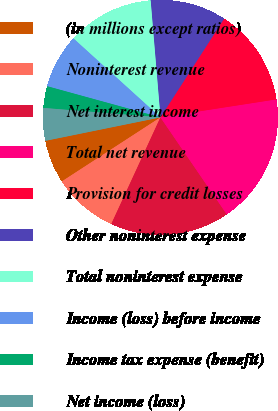Convert chart. <chart><loc_0><loc_0><loc_500><loc_500><pie_chart><fcel>(in millions except ratios)<fcel>Noninterest revenue<fcel>Net interest income<fcel>Total net revenue<fcel>Provision for credit losses<fcel>Other noninterest expense<fcel>Total noninterest expense<fcel>Income (loss) before income<fcel>Income tax expense (benefit)<fcel>Net income (loss)<nl><fcel>5.97%<fcel>8.96%<fcel>16.42%<fcel>17.91%<fcel>13.43%<fcel>10.45%<fcel>11.94%<fcel>7.46%<fcel>2.99%<fcel>4.48%<nl></chart> 